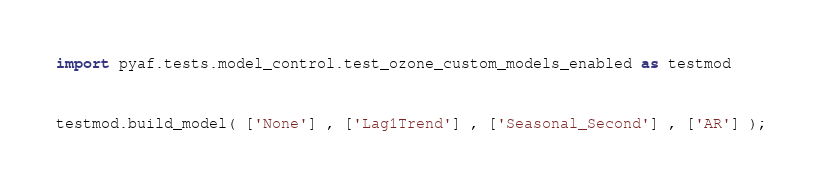Convert code to text. <code><loc_0><loc_0><loc_500><loc_500><_Python_>import pyaf.tests.model_control.test_ozone_custom_models_enabled as testmod


testmod.build_model( ['None'] , ['Lag1Trend'] , ['Seasonal_Second'] , ['AR'] );</code> 